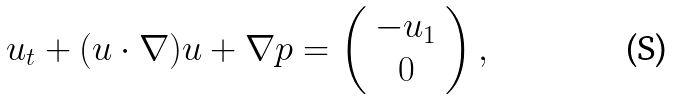Convert formula to latex. <formula><loc_0><loc_0><loc_500><loc_500>u _ { t } + ( u \cdot \nabla ) u + \nabla p = \left ( \begin{array} { c c } - u _ { 1 } \\ 0 \\ \end{array} \right ) ,</formula> 